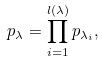<formula> <loc_0><loc_0><loc_500><loc_500>p _ { \lambda } = \prod _ { i = 1 } ^ { l ( \lambda ) } p _ { \lambda _ { i } } ,</formula> 